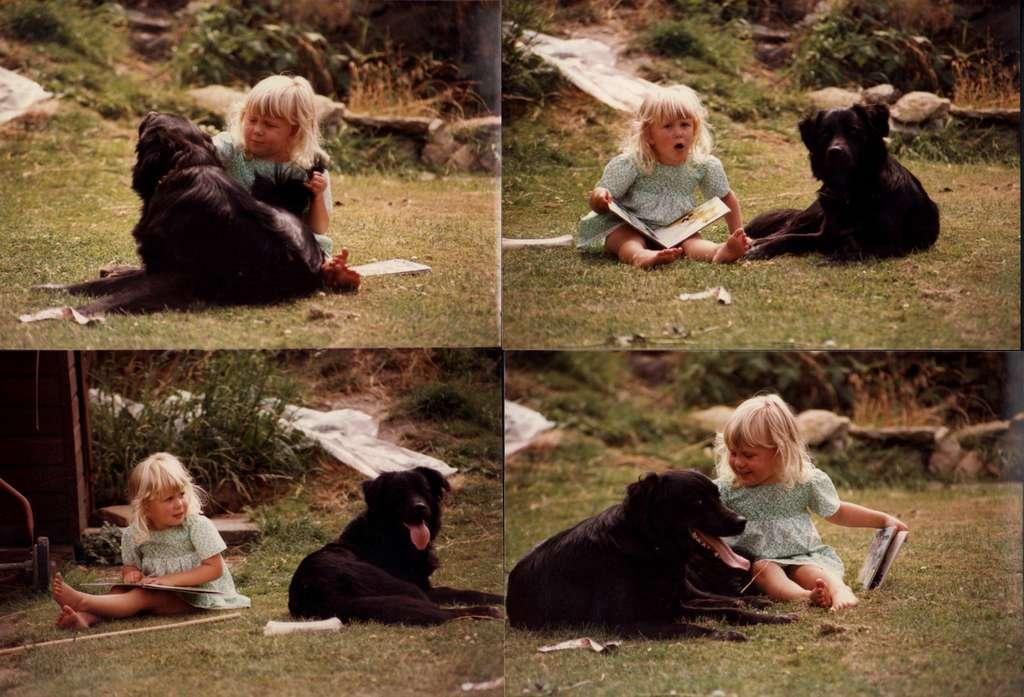Could you give a brief overview of what you see in this image? In this image I can see a girl holding a book and a dog sitting in the garden. 